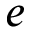Convert formula to latex. <formula><loc_0><loc_0><loc_500><loc_500>e</formula> 